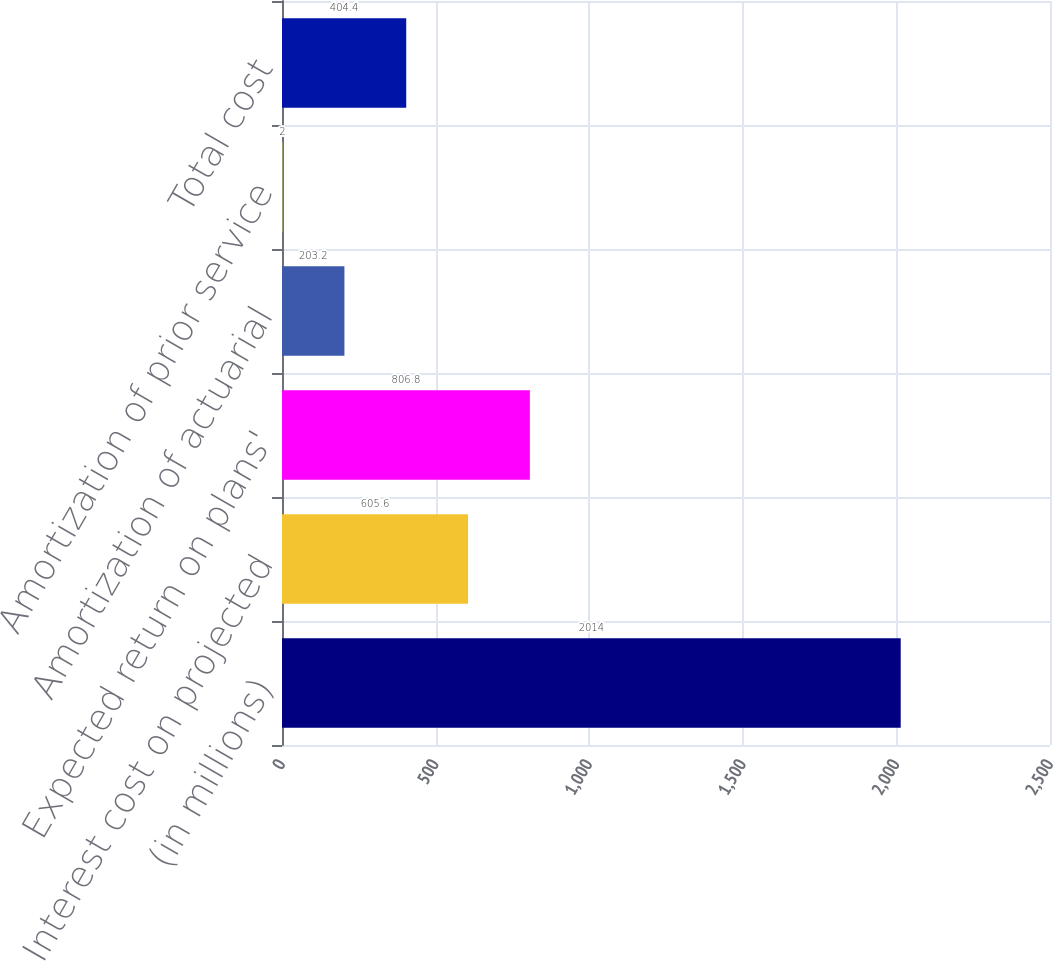Convert chart to OTSL. <chart><loc_0><loc_0><loc_500><loc_500><bar_chart><fcel>(in millions)<fcel>Interest cost on projected<fcel>Expected return on plans'<fcel>Amortization of actuarial<fcel>Amortization of prior service<fcel>Total cost<nl><fcel>2014<fcel>605.6<fcel>806.8<fcel>203.2<fcel>2<fcel>404.4<nl></chart> 